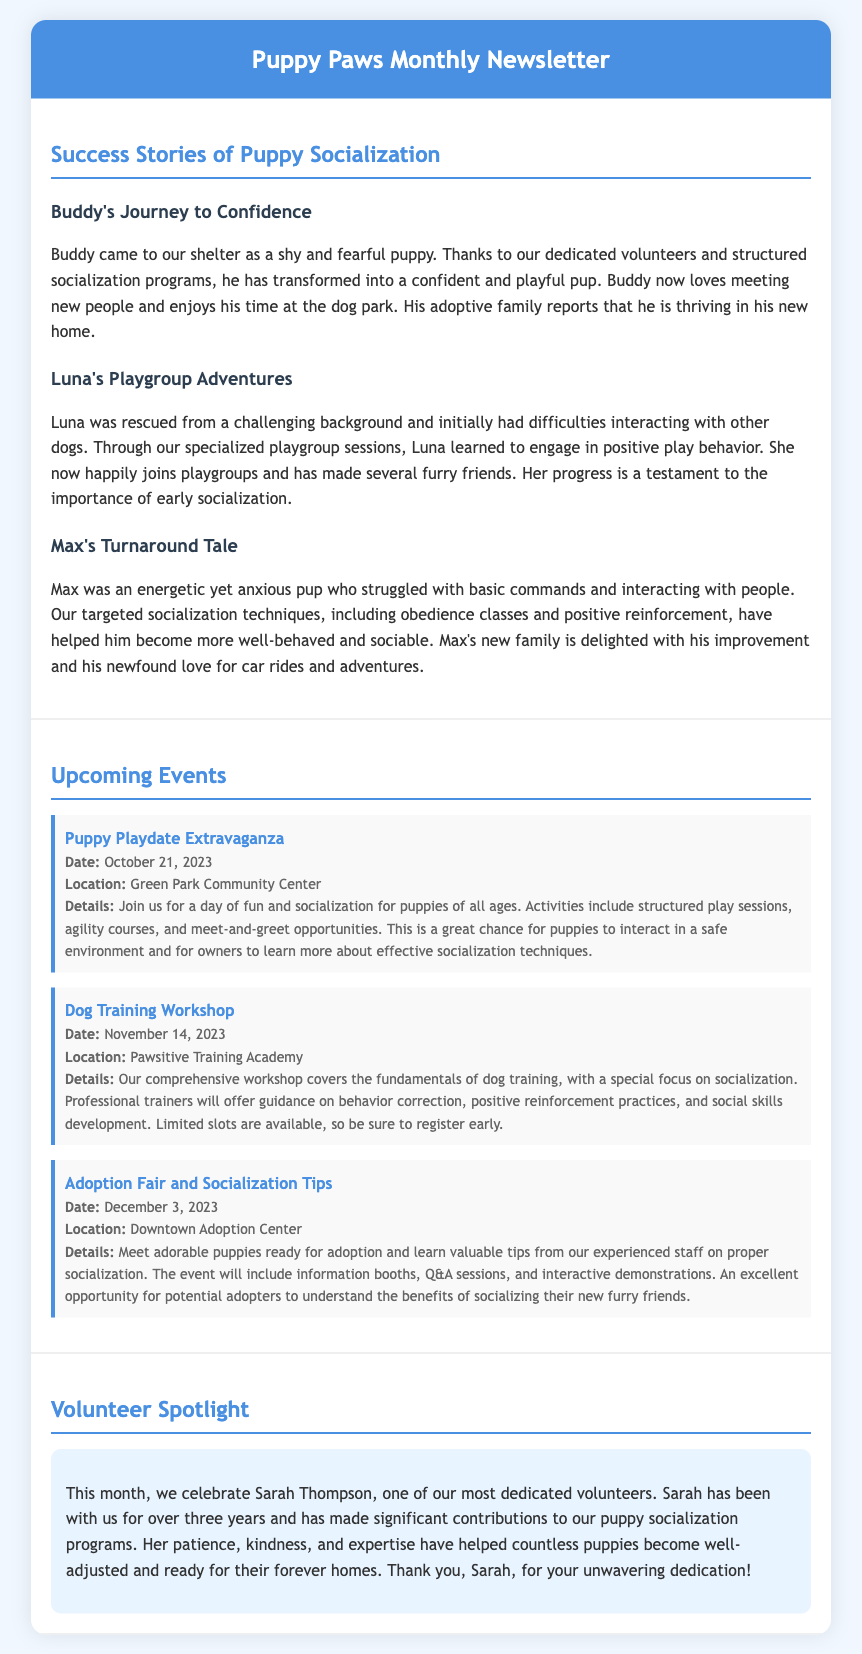what is the title of the newsletter? The title of the newsletter is prominently displayed in the header section of the document.
Answer: Puppy Paws Monthly Newsletter who is the featured volunteer this month? The document highlights a specific volunteer in the Volunteer Spotlight section.
Answer: Sarah Thompson what date is the Puppy Playdate Extravaganza event scheduled for? The date is provided in the Upcoming Events section mentioned right below the event title.
Answer: October 21, 2023 which puppy struggled with basic commands before socialization? The document describes multiple puppies, and this specific information is found in the success stories section.
Answer: Max what is the location of the Dog Training Workshop? The location is stated in the event details for the Dog Training Workshop in the Upcoming Events section.
Answer: Pawsitive Training Academy how many years has Sarah Thompson volunteered at the shelter? The duration of Sarah's volunteering is mentioned in the Volunteer Spotlight section of the newsletter.
Answer: Over three years what is the main focus of the Dog Training Workshop? This focus is highlighted in the details provided for the workshop in the document.
Answer: Socialization which puppy learned to engage in positive play behavior? This information is given in the success stories section focusing on how a puppy improved through socialization.
Answer: Luna 